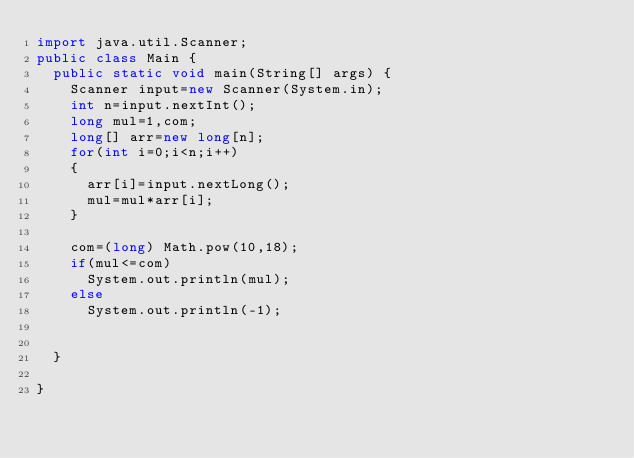Convert code to text. <code><loc_0><loc_0><loc_500><loc_500><_Java_>import java.util.Scanner;
public class Main {
	public static void main(String[] args) {
		Scanner input=new Scanner(System.in);
		int n=input.nextInt();
		long mul=1,com;
		long[] arr=new long[n];
		for(int i=0;i<n;i++)
		{
			arr[i]=input.nextLong();
			mul=mul*arr[i];
		}
	    
		com=(long) Math.pow(10,18);
		if(mul<=com)
			System.out.println(mul);
		else
			System.out.println(-1);
		
		
	}

}
</code> 